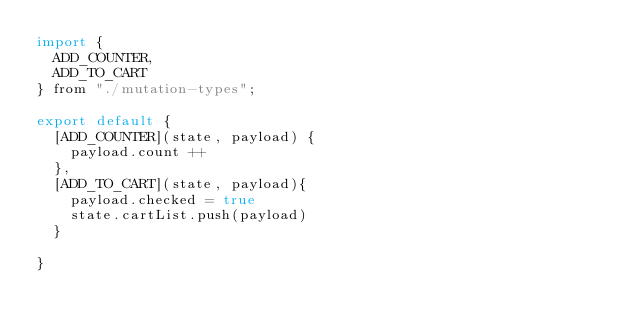<code> <loc_0><loc_0><loc_500><loc_500><_JavaScript_>import {
  ADD_COUNTER,
  ADD_TO_CART
} from "./mutation-types";

export default {
  [ADD_COUNTER](state, payload) {
    payload.count ++
  },
  [ADD_TO_CART](state, payload){
    payload.checked = true
    state.cartList.push(payload)
  }

}
</code> 